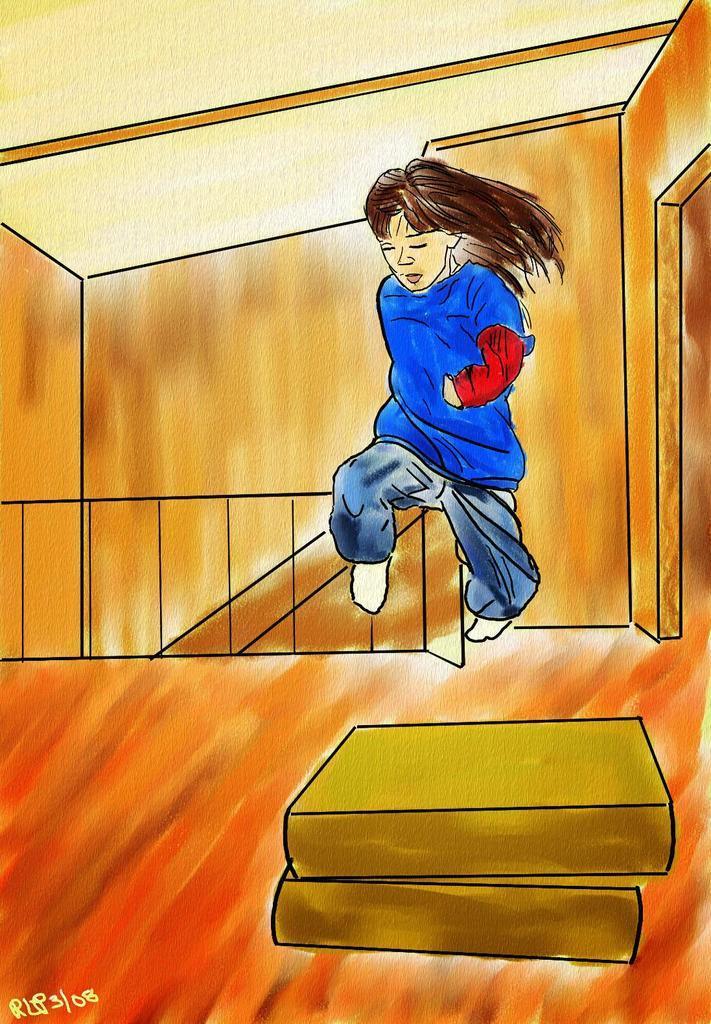Describe this image in one or two sentences. This picture seems to be an animated image and we can see a person wearing blue color dress and jumping in the air and in the foreground we can see there are some objects. In the background we can see the wall and some other objects. In the bottom left corner we can see the watermark on the image. 